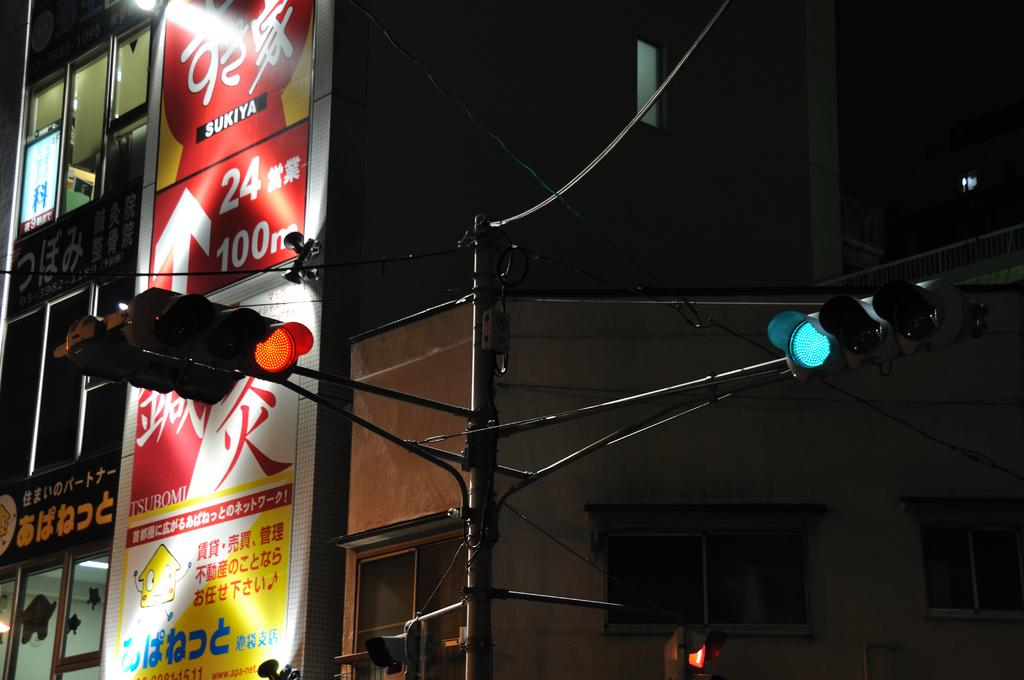<image>
Render a clear and concise summary of the photo. A street scene with a sign in Chinese lettering, the number 100 is visible. 